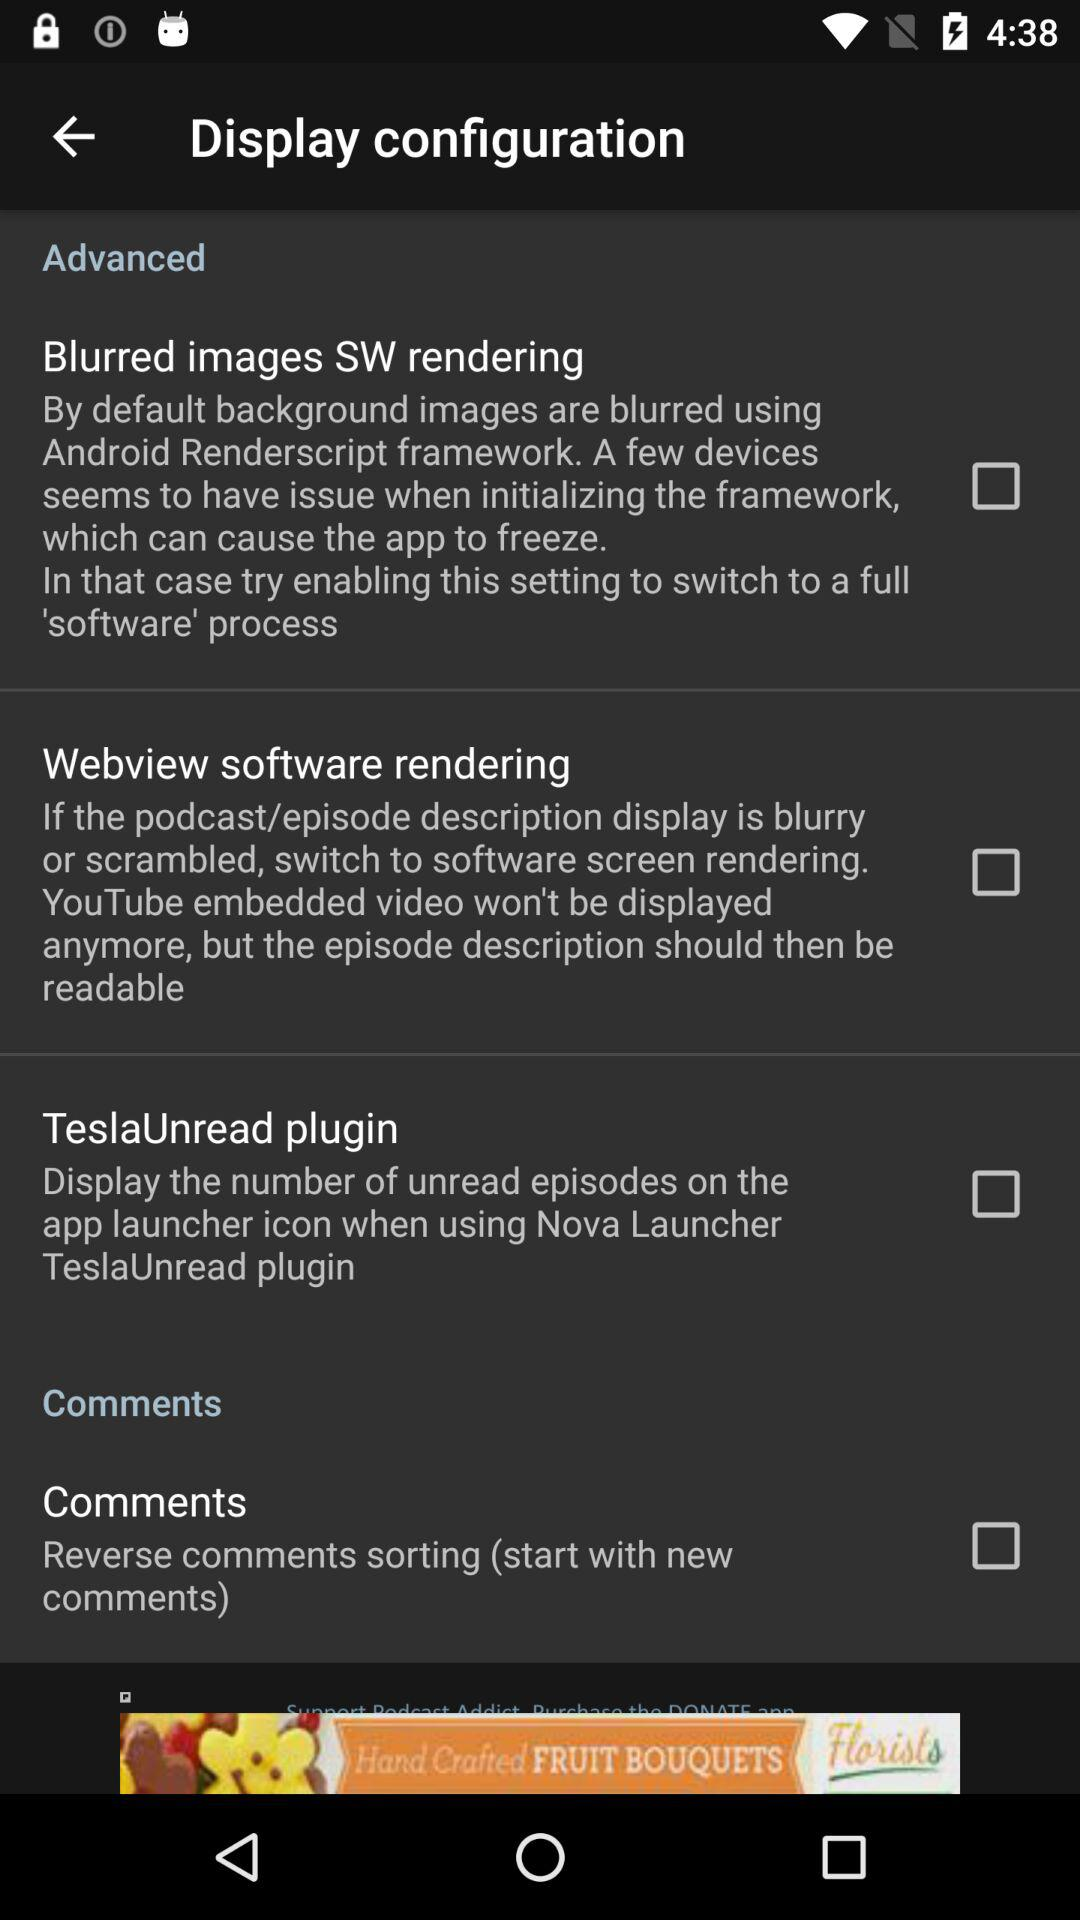How many items are in the advanced section?
Answer the question using a single word or phrase. 3 